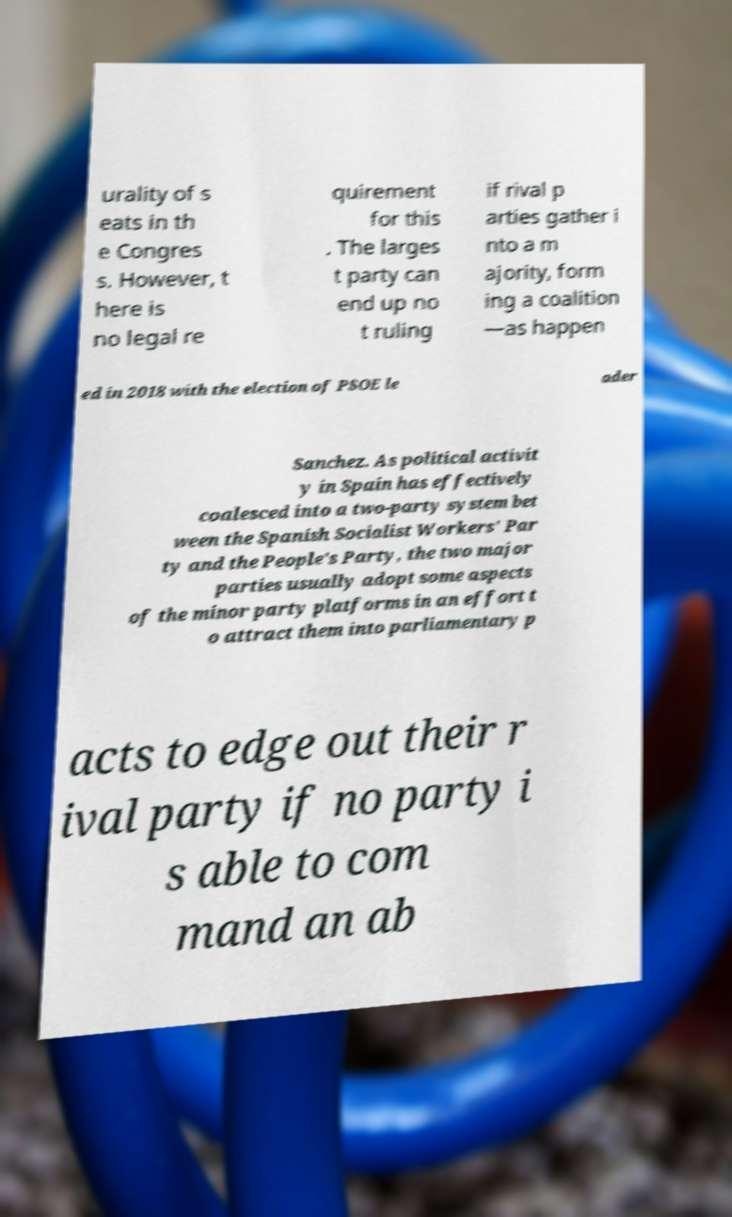I need the written content from this picture converted into text. Can you do that? urality of s eats in th e Congres s. However, t here is no legal re quirement for this . The larges t party can end up no t ruling if rival p arties gather i nto a m ajority, form ing a coalition —as happen ed in 2018 with the election of PSOE le ader Sanchez. As political activit y in Spain has effectively coalesced into a two-party system bet ween the Spanish Socialist Workers' Par ty and the People's Party, the two major parties usually adopt some aspects of the minor party platforms in an effort t o attract them into parliamentary p acts to edge out their r ival party if no party i s able to com mand an ab 